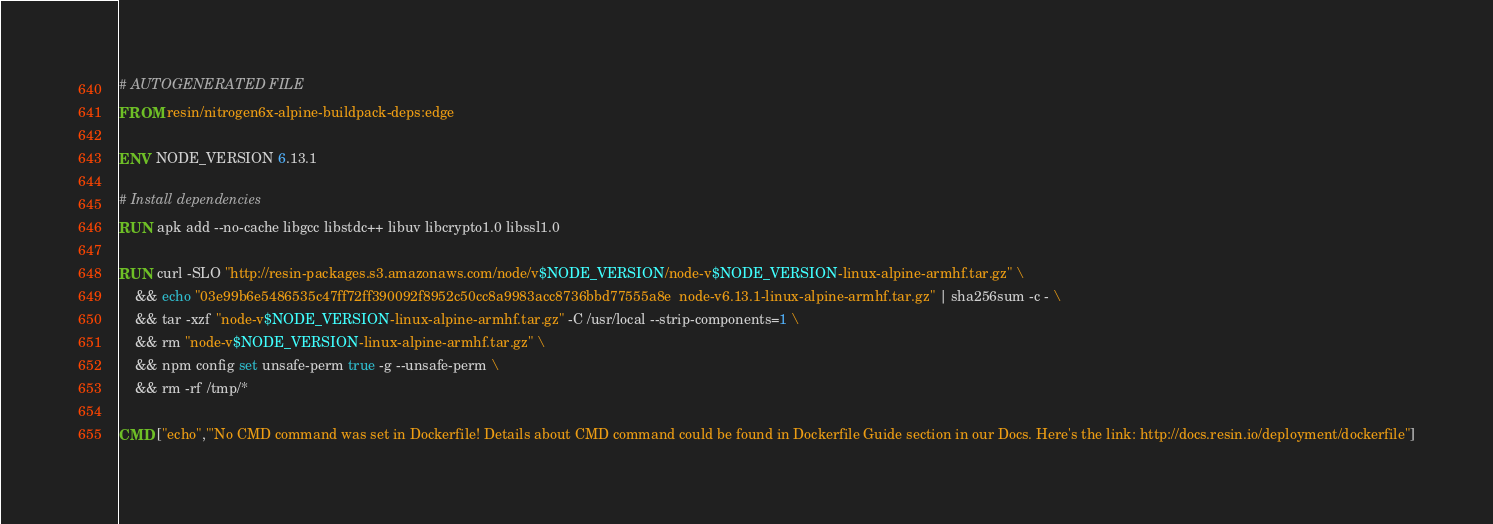<code> <loc_0><loc_0><loc_500><loc_500><_Dockerfile_># AUTOGENERATED FILE
FROM resin/nitrogen6x-alpine-buildpack-deps:edge

ENV NODE_VERSION 6.13.1

# Install dependencies
RUN apk add --no-cache libgcc libstdc++ libuv libcrypto1.0 libssl1.0

RUN curl -SLO "http://resin-packages.s3.amazonaws.com/node/v$NODE_VERSION/node-v$NODE_VERSION-linux-alpine-armhf.tar.gz" \
	&& echo "03e99b6e5486535c47ff72ff390092f8952c50cc8a9983acc8736bbd77555a8e  node-v6.13.1-linux-alpine-armhf.tar.gz" | sha256sum -c - \
	&& tar -xzf "node-v$NODE_VERSION-linux-alpine-armhf.tar.gz" -C /usr/local --strip-components=1 \
	&& rm "node-v$NODE_VERSION-linux-alpine-armhf.tar.gz" \
	&& npm config set unsafe-perm true -g --unsafe-perm \
	&& rm -rf /tmp/*

CMD ["echo","'No CMD command was set in Dockerfile! Details about CMD command could be found in Dockerfile Guide section in our Docs. Here's the link: http://docs.resin.io/deployment/dockerfile"]
</code> 